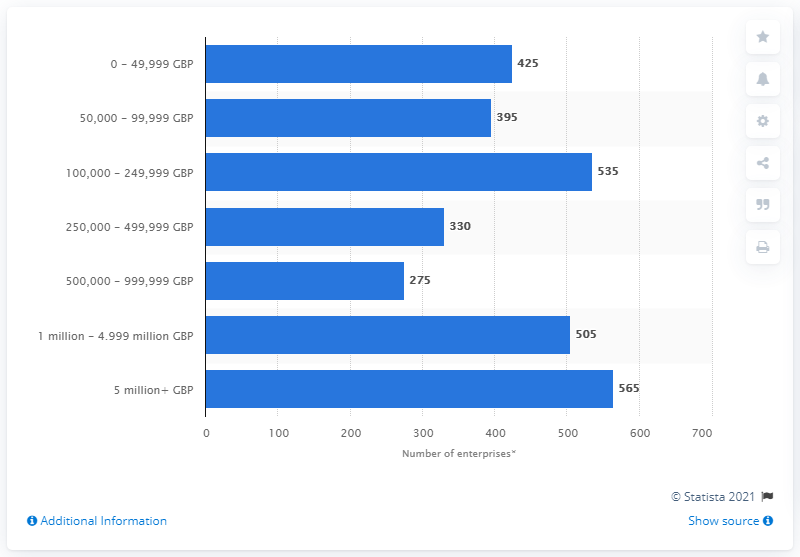Point out several critical features in this image. As of March 2020, there were 565 enterprises in the chemicals and chemical products manufacturing sector that had a turnover of more than five million GBP. 